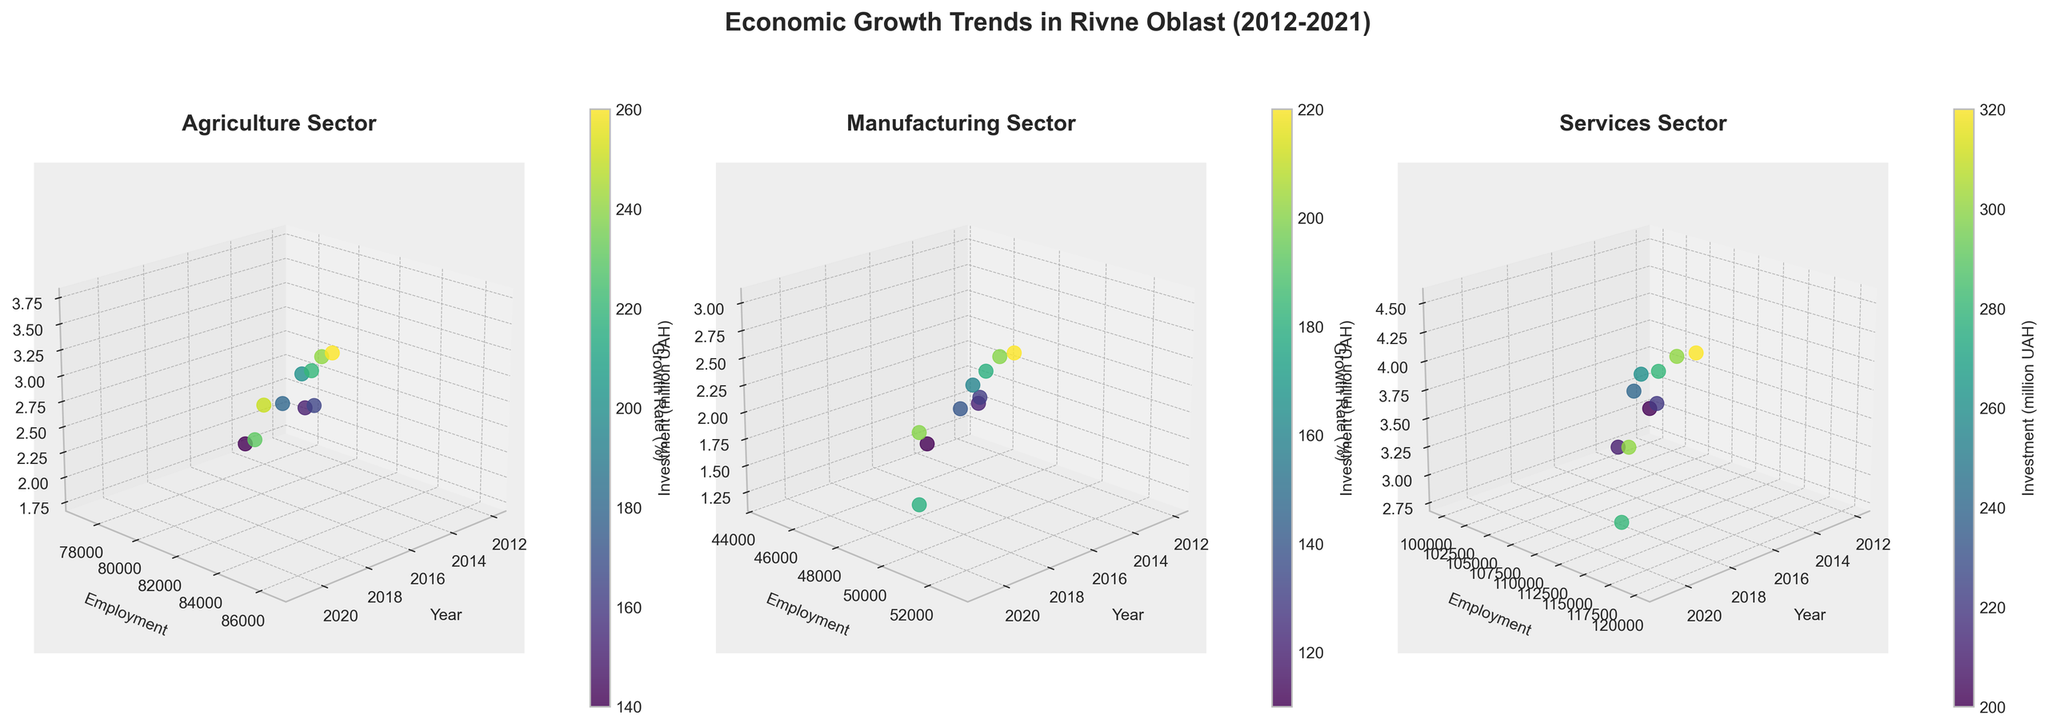In which year did the Agriculture sector reach its highest growth rate? The highest growth rate for the Agriculture sector is indicated by the peak on the Growth Rate axis in the Agriculture subplot. Observing the peaks, the highest growth rate is 3.7 in 2019.
Answer: 2019 What has been the general trend in Employment for the Services sector over the decade? Observing the Services subplot, the Employment values generally increase from 100,000 in 2012 through 2021, with minor fluctuations.
Answer: Increasing Which sector had the lowest investment in 2014? Looking at the color bar for the 2014 data points, the Manufacturing sector shows the lowest investment (darkest point) around 110 million UAH.
Answer: Manufacturing Between Agriculture and Services sectors, which one had higher Employment in 2017? By comparing the Employment axis in the Agriculture and Services subplots for the year 2017, we see that the Services sector had an Employment of 112,000, whereas the Agriculture sector had 83,500.
Answer: Services How does the Growth Rate in the Manufacturing sector change from 2020 to 2021? In the Manufacturing subplot, observe the Growth Rate axis for the years 2020 and 2021. The point height is lower in 2020 (1.5%) and increases in 2021 (2.3%).
Answer: It increases What is the average Growth Rate for the Services sector from 2015 to 2017? In the Services subplot, locate the Growth Rates for the years 2015 (3.5%), 2016 (3.8%), and 2017 (4.0%). The average is (3.5 + 3.8 + 4.0)/3 = 3.77%.
Answer: 3.77% Compare the Investment trend in Agriculture and Manufacturing sectors over the decade. Observing the color gradient in both Agriculture and Manufacturing subplots, the Agriculture sector shows a consistent increase in investment, whereas Manufacturing shows a modest increase with more fluctuations.
Answer: Agriculture has a more consistent increase Which sector showed a sharper decline in Growth Rate during 2020? Comparing the Growth Rate axis for all three sectors, both Agriculture and Services sectors show a decline, but the Services sector had a sharper decline from 4.5 in 2019 to 3.0 in 2020.
Answer: Services 